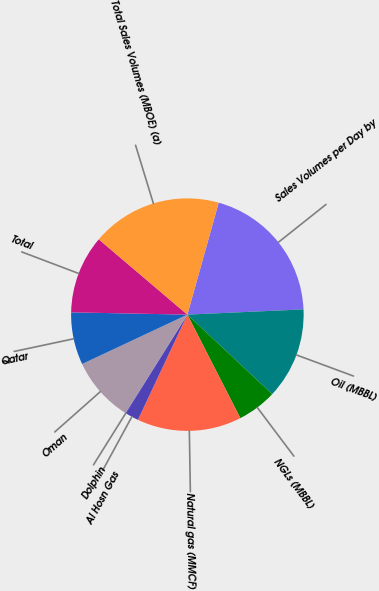Convert chart to OTSL. <chart><loc_0><loc_0><loc_500><loc_500><pie_chart><fcel>Sales Volumes per Day by<fcel>Oil (MBBL)<fcel>NGLs (MBBL)<fcel>Natural gas (MMCF)<fcel>Al Hosn Gas<fcel>Dolphin<fcel>Oman<fcel>Qatar<fcel>Total<fcel>Total Sales Volumes (MBOE) (a)<nl><fcel>19.94%<fcel>12.71%<fcel>5.48%<fcel>14.52%<fcel>1.87%<fcel>0.06%<fcel>9.1%<fcel>7.29%<fcel>10.9%<fcel>18.13%<nl></chart> 